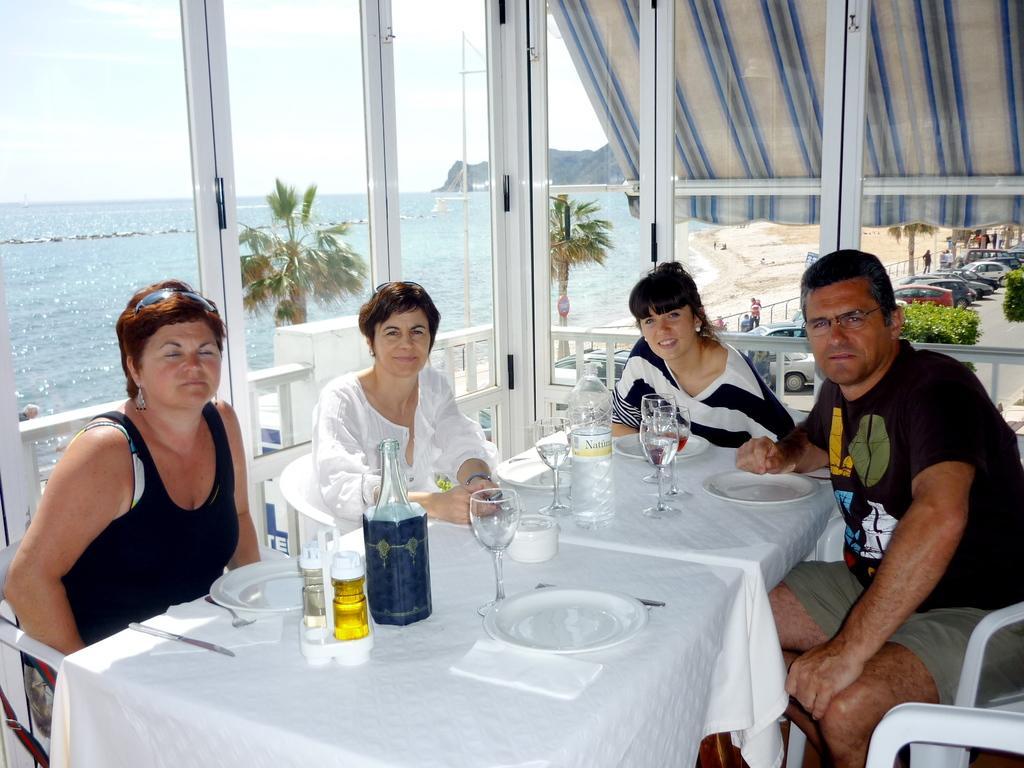Could you give a brief overview of what you see in this image? These persons are sitting on a chair. This is a freshwater river. On this table there are bottles, glasses and plates. These are plants. Far there are vehicles on road. 